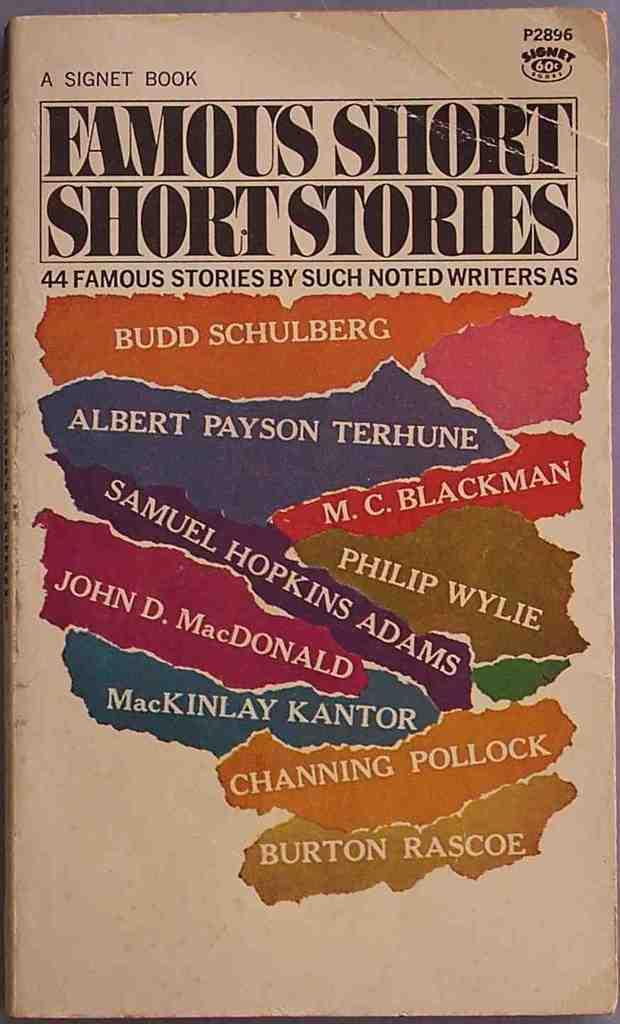<image>
Write a terse but informative summary of the picture. Famous Short Short Stories was published by Signet 